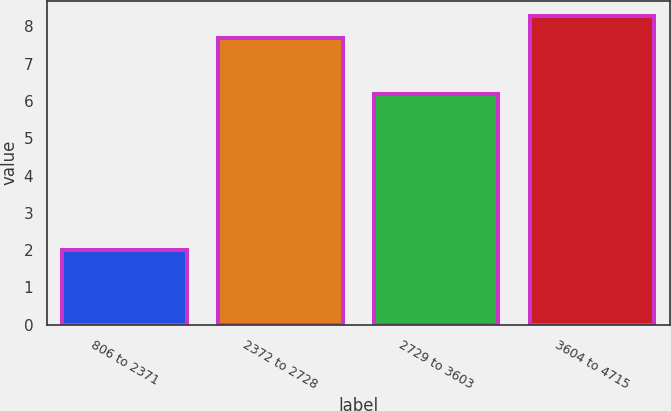Convert chart to OTSL. <chart><loc_0><loc_0><loc_500><loc_500><bar_chart><fcel>806 to 2371<fcel>2372 to 2728<fcel>2729 to 3603<fcel>3604 to 4715<nl><fcel>2<fcel>7.7<fcel>6.2<fcel>8.28<nl></chart> 